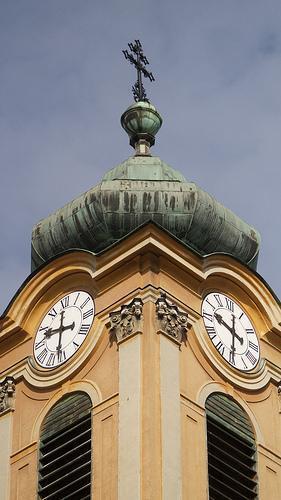How many clocks are there?
Give a very brief answer. 2. 